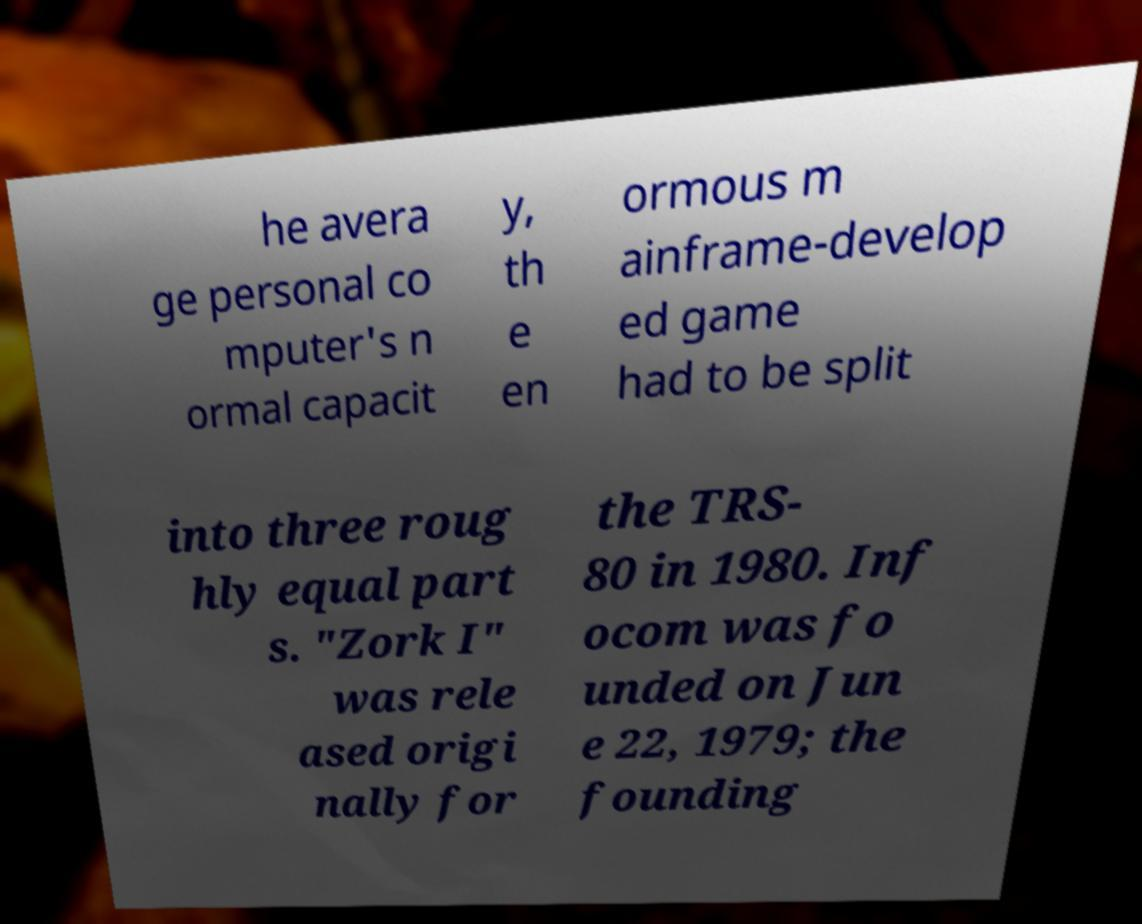Can you read and provide the text displayed in the image?This photo seems to have some interesting text. Can you extract and type it out for me? he avera ge personal co mputer's n ormal capacit y, th e en ormous m ainframe-develop ed game had to be split into three roug hly equal part s. "Zork I" was rele ased origi nally for the TRS- 80 in 1980. Inf ocom was fo unded on Jun e 22, 1979; the founding 